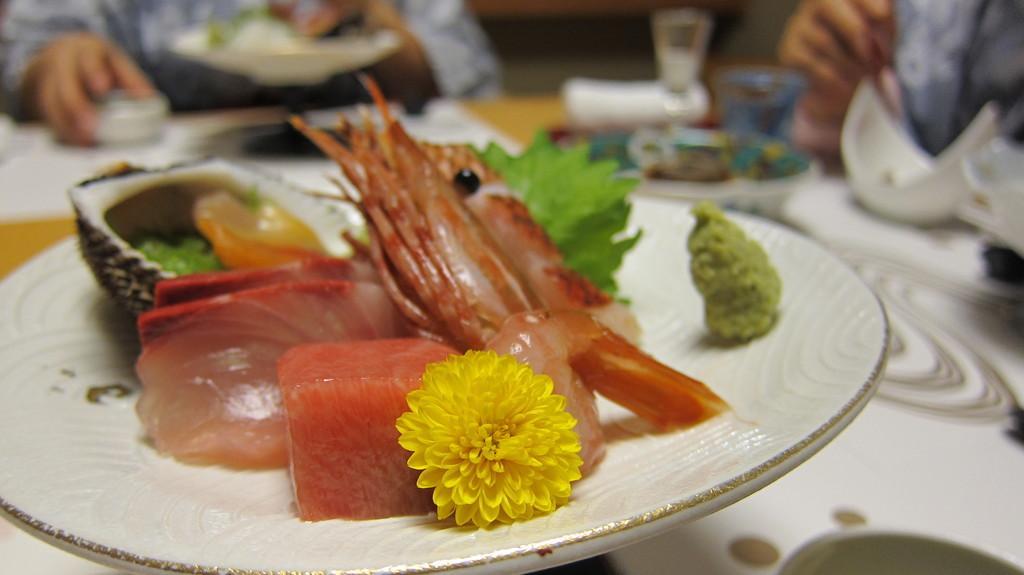Describe this image in one or two sentences. In this image, we can see some food items on a plate is placed on the surface. We can also see some objects like a glass. There are a few people. Among them, a person is holding an object. 